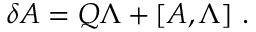<formula> <loc_0><loc_0><loc_500><loc_500>\delta A = Q \Lambda + [ A , \Lambda ] \ .</formula> 